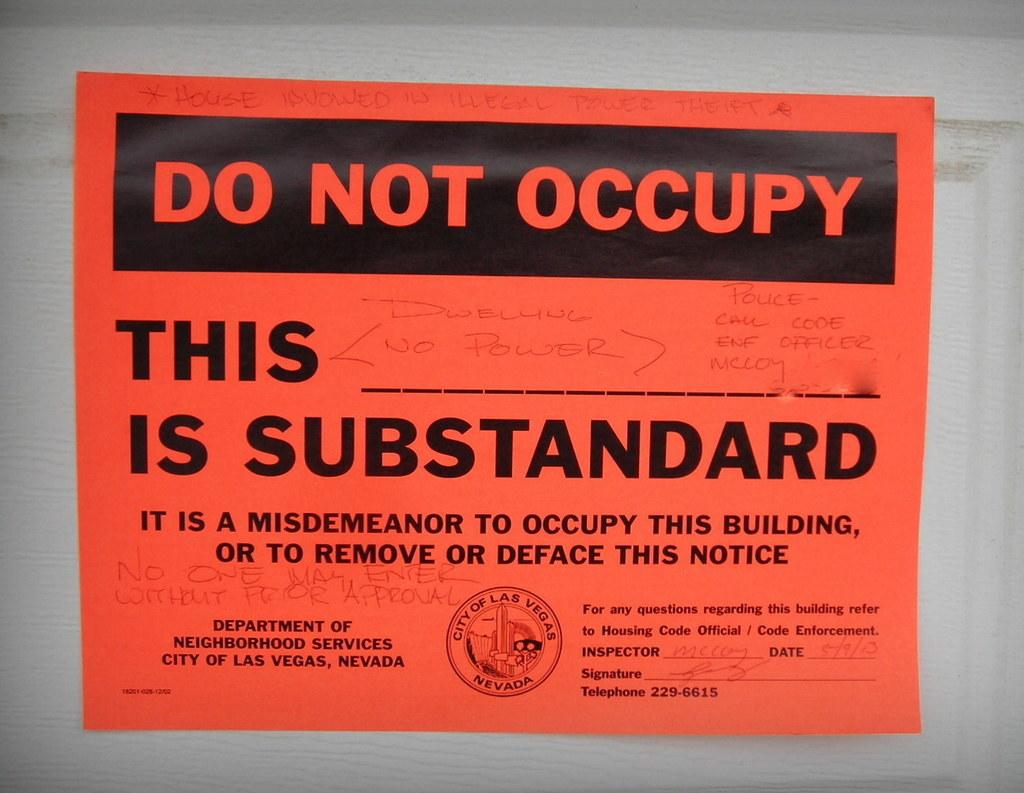Do not do what?
Your answer should be very brief. Occupy. What should people not do here?
Your answer should be compact. Occupy. 